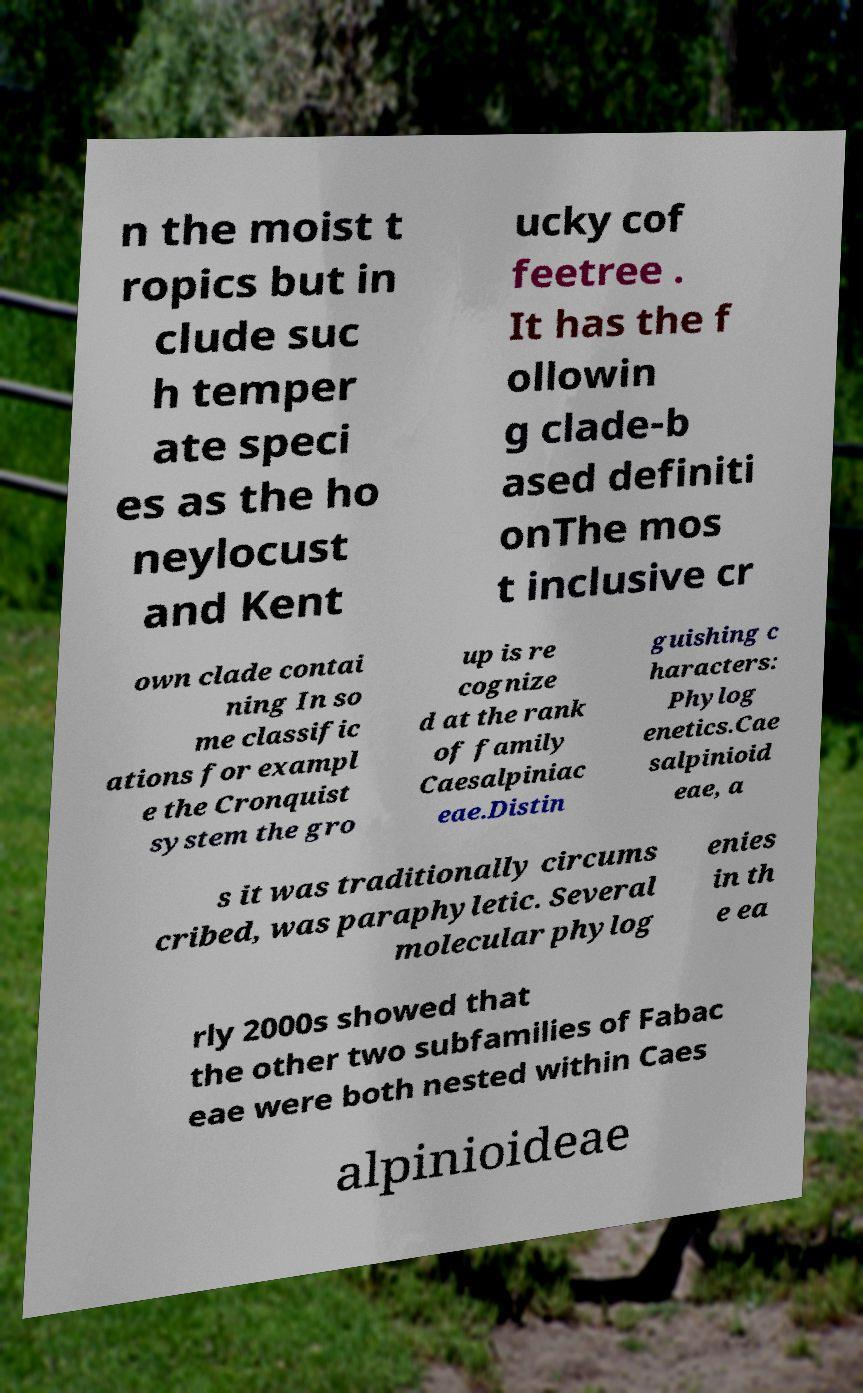Can you accurately transcribe the text from the provided image for me? n the moist t ropics but in clude suc h temper ate speci es as the ho neylocust and Kent ucky cof feetree . It has the f ollowin g clade-b ased definiti onThe mos t inclusive cr own clade contai ning In so me classific ations for exampl e the Cronquist system the gro up is re cognize d at the rank of family Caesalpiniac eae.Distin guishing c haracters: Phylog enetics.Cae salpinioid eae, a s it was traditionally circums cribed, was paraphyletic. Several molecular phylog enies in th e ea rly 2000s showed that the other two subfamilies of Fabac eae were both nested within Caes alpinioideae 